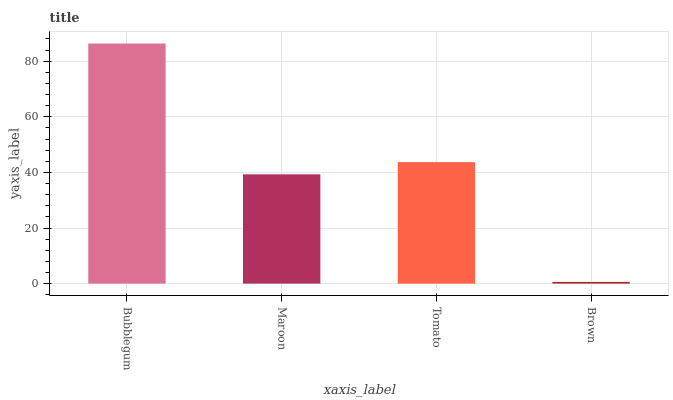Is Brown the minimum?
Answer yes or no. Yes. Is Bubblegum the maximum?
Answer yes or no. Yes. Is Maroon the minimum?
Answer yes or no. No. Is Maroon the maximum?
Answer yes or no. No. Is Bubblegum greater than Maroon?
Answer yes or no. Yes. Is Maroon less than Bubblegum?
Answer yes or no. Yes. Is Maroon greater than Bubblegum?
Answer yes or no. No. Is Bubblegum less than Maroon?
Answer yes or no. No. Is Tomato the high median?
Answer yes or no. Yes. Is Maroon the low median?
Answer yes or no. Yes. Is Bubblegum the high median?
Answer yes or no. No. Is Bubblegum the low median?
Answer yes or no. No. 